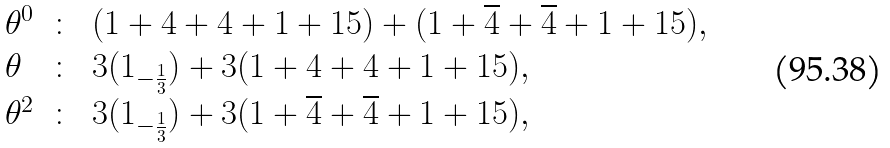<formula> <loc_0><loc_0><loc_500><loc_500>\begin{array} { l c l } \theta ^ { 0 } & \colon & ( 1 + 4 + 4 + 1 + 1 5 ) + ( 1 + \overline { 4 } + \overline { 4 } + 1 + 1 5 ) , \\ \theta & \colon & 3 ( 1 _ { - \frac { 1 } { 3 } } ) + 3 ( 1 + 4 + 4 + 1 + 1 5 ) , \\ \theta ^ { 2 } & \colon & 3 ( 1 _ { - \frac { 1 } { 3 } } ) + 3 ( 1 + \overline { 4 } + \overline { 4 } + 1 + 1 5 ) , \end{array}</formula> 